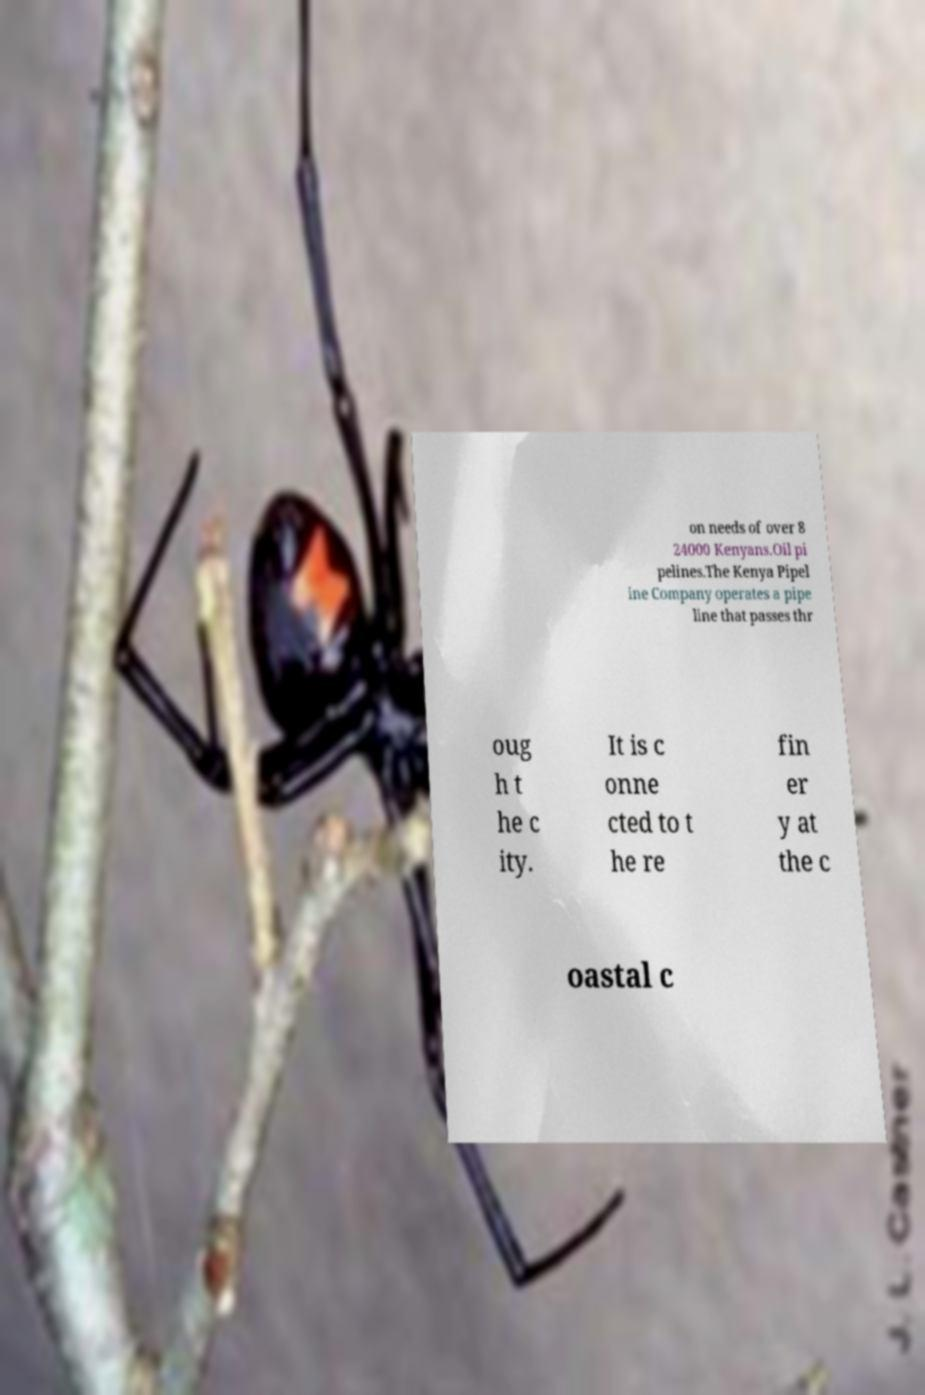For documentation purposes, I need the text within this image transcribed. Could you provide that? on needs of over 8 24000 Kenyans.Oil pi pelines.The Kenya Pipel ine Company operates a pipe line that passes thr oug h t he c ity. It is c onne cted to t he re fin er y at the c oastal c 